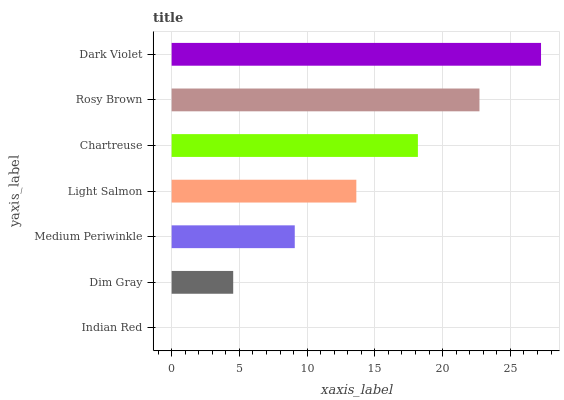Is Indian Red the minimum?
Answer yes or no. Yes. Is Dark Violet the maximum?
Answer yes or no. Yes. Is Dim Gray the minimum?
Answer yes or no. No. Is Dim Gray the maximum?
Answer yes or no. No. Is Dim Gray greater than Indian Red?
Answer yes or no. Yes. Is Indian Red less than Dim Gray?
Answer yes or no. Yes. Is Indian Red greater than Dim Gray?
Answer yes or no. No. Is Dim Gray less than Indian Red?
Answer yes or no. No. Is Light Salmon the high median?
Answer yes or no. Yes. Is Light Salmon the low median?
Answer yes or no. Yes. Is Rosy Brown the high median?
Answer yes or no. No. Is Rosy Brown the low median?
Answer yes or no. No. 